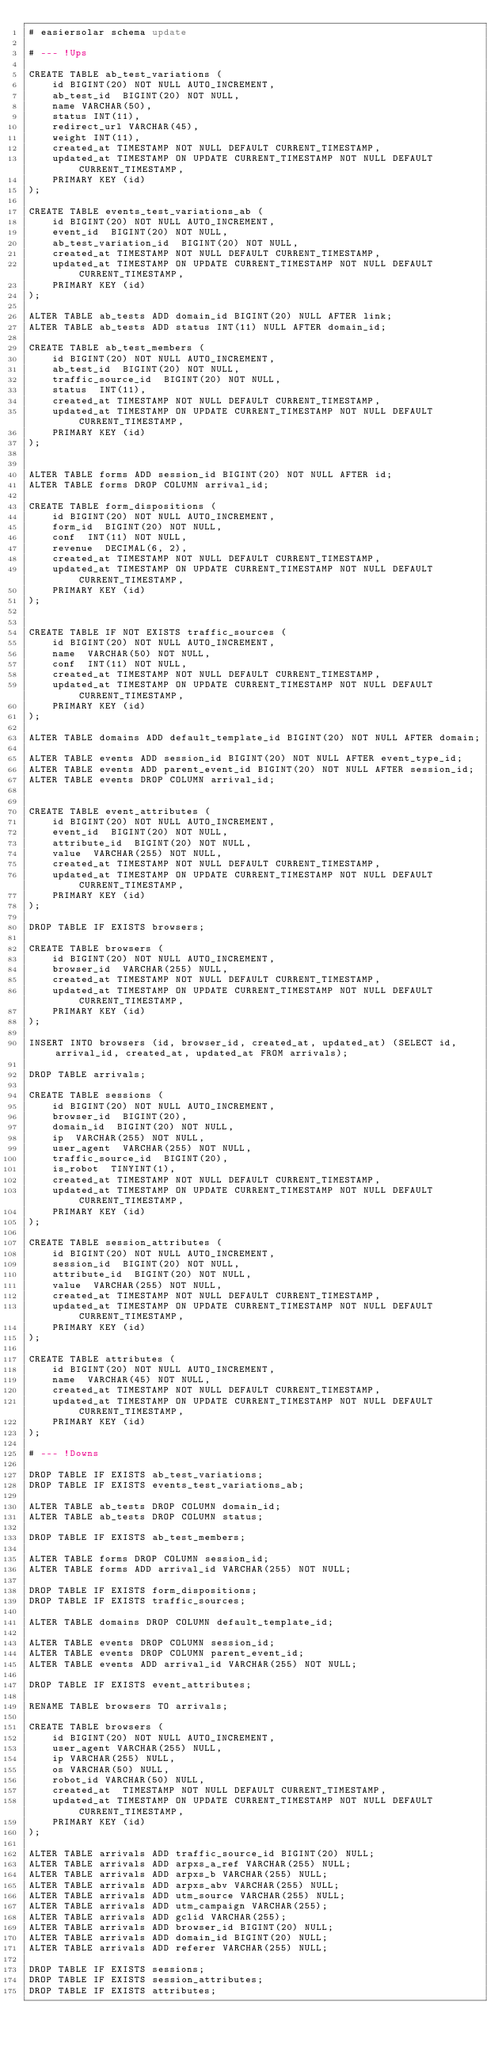<code> <loc_0><loc_0><loc_500><loc_500><_SQL_># easiersolar schema update

# --- !Ups

CREATE TABLE ab_test_variations (
    id BIGINT(20) NOT NULL AUTO_INCREMENT,
    ab_test_id  BIGINT(20) NOT NULL,
    name VARCHAR(50),
    status INT(11),
    redirect_url VARCHAR(45),
    weight INT(11),
    created_at TIMESTAMP NOT NULL DEFAULT CURRENT_TIMESTAMP,
    updated_at TIMESTAMP ON UPDATE CURRENT_TIMESTAMP NOT NULL DEFAULT CURRENT_TIMESTAMP,
    PRIMARY KEY (id)
);

CREATE TABLE events_test_variations_ab (
    id BIGINT(20) NOT NULL AUTO_INCREMENT,
    event_id  BIGINT(20) NOT NULL,
    ab_test_variation_id  BIGINT(20) NOT NULL,
    created_at TIMESTAMP NOT NULL DEFAULT CURRENT_TIMESTAMP,
    updated_at TIMESTAMP ON UPDATE CURRENT_TIMESTAMP NOT NULL DEFAULT CURRENT_TIMESTAMP,
    PRIMARY KEY (id)
);

ALTER TABLE ab_tests ADD domain_id BIGINT(20) NULL AFTER link;
ALTER TABLE ab_tests ADD status INT(11) NULL AFTER domain_id;

CREATE TABLE ab_test_members (
    id BIGINT(20) NOT NULL AUTO_INCREMENT,
    ab_test_id  BIGINT(20) NOT NULL,
    traffic_source_id  BIGINT(20) NOT NULL,
    status  INT(11),
    created_at TIMESTAMP NOT NULL DEFAULT CURRENT_TIMESTAMP,
    updated_at TIMESTAMP ON UPDATE CURRENT_TIMESTAMP NOT NULL DEFAULT CURRENT_TIMESTAMP,
    PRIMARY KEY (id)
);


ALTER TABLE forms ADD session_id BIGINT(20) NOT NULL AFTER id;
ALTER TABLE forms DROP COLUMN arrival_id;

CREATE TABLE form_dispositions (
    id BIGINT(20) NOT NULL AUTO_INCREMENT,
    form_id  BIGINT(20) NOT NULL,
    conf  INT(11) NOT NULL,
    revenue  DECIMAL(6, 2),
    created_at TIMESTAMP NOT NULL DEFAULT CURRENT_TIMESTAMP,
    updated_at TIMESTAMP ON UPDATE CURRENT_TIMESTAMP NOT NULL DEFAULT CURRENT_TIMESTAMP,
    PRIMARY KEY (id)
);


CREATE TABLE IF NOT EXISTS traffic_sources (
    id BIGINT(20) NOT NULL AUTO_INCREMENT,
    name  VARCHAR(50) NOT NULL,
    conf  INT(11) NOT NULL,
    created_at TIMESTAMP NOT NULL DEFAULT CURRENT_TIMESTAMP,
    updated_at TIMESTAMP ON UPDATE CURRENT_TIMESTAMP NOT NULL DEFAULT CURRENT_TIMESTAMP,
    PRIMARY KEY (id)
);

ALTER TABLE domains ADD default_template_id BIGINT(20) NOT NULL AFTER domain;

ALTER TABLE events ADD session_id BIGINT(20) NOT NULL AFTER event_type_id;
ALTER TABLE events ADD parent_event_id BIGINT(20) NOT NULL AFTER session_id;
ALTER TABLE events DROP COLUMN arrival_id;


CREATE TABLE event_attributes (
    id BIGINT(20) NOT NULL AUTO_INCREMENT,
    event_id  BIGINT(20) NOT NULL,
    attribute_id  BIGINT(20) NOT NULL,
    value  VARCHAR(255) NOT NULL,
    created_at TIMESTAMP NOT NULL DEFAULT CURRENT_TIMESTAMP,
    updated_at TIMESTAMP ON UPDATE CURRENT_TIMESTAMP NOT NULL DEFAULT CURRENT_TIMESTAMP,
    PRIMARY KEY (id)
);

DROP TABLE IF EXISTS browsers;

CREATE TABLE browsers (
    id BIGINT(20) NOT NULL AUTO_INCREMENT,
    browser_id  VARCHAR(255) NULL,
    created_at TIMESTAMP NOT NULL DEFAULT CURRENT_TIMESTAMP,
    updated_at TIMESTAMP ON UPDATE CURRENT_TIMESTAMP NOT NULL DEFAULT CURRENT_TIMESTAMP,
    PRIMARY KEY (id)
);

INSERT INTO browsers (id, browser_id, created_at, updated_at) (SELECT id, arrival_id, created_at, updated_at FROM arrivals);

DROP TABLE arrivals;

CREATE TABLE sessions (
    id BIGINT(20) NOT NULL AUTO_INCREMENT,
    browser_id  BIGINT(20),
    domain_id  BIGINT(20) NOT NULL,
    ip  VARCHAR(255) NOT NULL,
    user_agent  VARCHAR(255) NOT NULL,
    traffic_source_id  BIGINT(20),
    is_robot  TINYINT(1),
    created_at TIMESTAMP NOT NULL DEFAULT CURRENT_TIMESTAMP,
    updated_at TIMESTAMP ON UPDATE CURRENT_TIMESTAMP NOT NULL DEFAULT CURRENT_TIMESTAMP,
    PRIMARY KEY (id)
);

CREATE TABLE session_attributes (
    id BIGINT(20) NOT NULL AUTO_INCREMENT,
    session_id  BIGINT(20) NOT NULL,
    attribute_id  BIGINT(20) NOT NULL,
    value  VARCHAR(255) NOT NULL,
    created_at TIMESTAMP NOT NULL DEFAULT CURRENT_TIMESTAMP,
    updated_at TIMESTAMP ON UPDATE CURRENT_TIMESTAMP NOT NULL DEFAULT CURRENT_TIMESTAMP,
    PRIMARY KEY (id)
);

CREATE TABLE attributes (
    id BIGINT(20) NOT NULL AUTO_INCREMENT,
    name  VARCHAR(45) NOT NULL,
    created_at TIMESTAMP NOT NULL DEFAULT CURRENT_TIMESTAMP,
    updated_at TIMESTAMP ON UPDATE CURRENT_TIMESTAMP NOT NULL DEFAULT CURRENT_TIMESTAMP,
    PRIMARY KEY (id)
);

# --- !Downs

DROP TABLE IF EXISTS ab_test_variations;
DROP TABLE IF EXISTS events_test_variations_ab;

ALTER TABLE ab_tests DROP COLUMN domain_id;
ALTER TABLE ab_tests DROP COLUMN status;

DROP TABLE IF EXISTS ab_test_members;

ALTER TABLE forms DROP COLUMN session_id;
ALTER TABLE forms ADD arrival_id VARCHAR(255) NOT NULL;

DROP TABLE IF EXISTS form_dispositions;
DROP TABLE IF EXISTS traffic_sources;

ALTER TABLE domains DROP COLUMN default_template_id;

ALTER TABLE events DROP COLUMN session_id;
ALTER TABLE events DROP COLUMN parent_event_id;
ALTER TABLE events ADD arrival_id VARCHAR(255) NOT NULL;

DROP TABLE IF EXISTS event_attributes;

RENAME TABLE browsers TO arrivals;

CREATE TABLE browsers (
    id BIGINT(20) NOT NULL AUTO_INCREMENT,
    user_agent VARCHAR(255) NULL,
    ip VARCHAR(255) NULL,
    os VARCHAR(50) NULL,
    robot_id VARCHAR(50) NULL,
    created_at  TIMESTAMP NOT NULL DEFAULT CURRENT_TIMESTAMP,
    updated_at TIMESTAMP ON UPDATE CURRENT_TIMESTAMP NOT NULL DEFAULT CURRENT_TIMESTAMP,
    PRIMARY KEY (id)
);

ALTER TABLE arrivals ADD traffic_source_id BIGINT(20) NULL;
ALTER TABLE arrivals ADD arpxs_a_ref VARCHAR(255) NULL;
ALTER TABLE arrivals ADD arpxs_b VARCHAR(255) NULL;
ALTER TABLE arrivals ADD arpxs_abv VARCHAR(255) NULL;
ALTER TABLE arrivals ADD utm_source VARCHAR(255) NULL;
ALTER TABLE arrivals ADD utm_campaign VARCHAR(255);
ALTER TABLE arrivals ADD gclid VARCHAR(255);
ALTER TABLE arrivals ADD browser_id BIGINT(20) NULL;
ALTER TABLE arrivals ADD domain_id BIGINT(20) NULL;
ALTER TABLE arrivals ADD referer VARCHAR(255) NULL;

DROP TABLE IF EXISTS sessions;
DROP TABLE IF EXISTS session_attributes;
DROP TABLE IF EXISTS attributes;</code> 